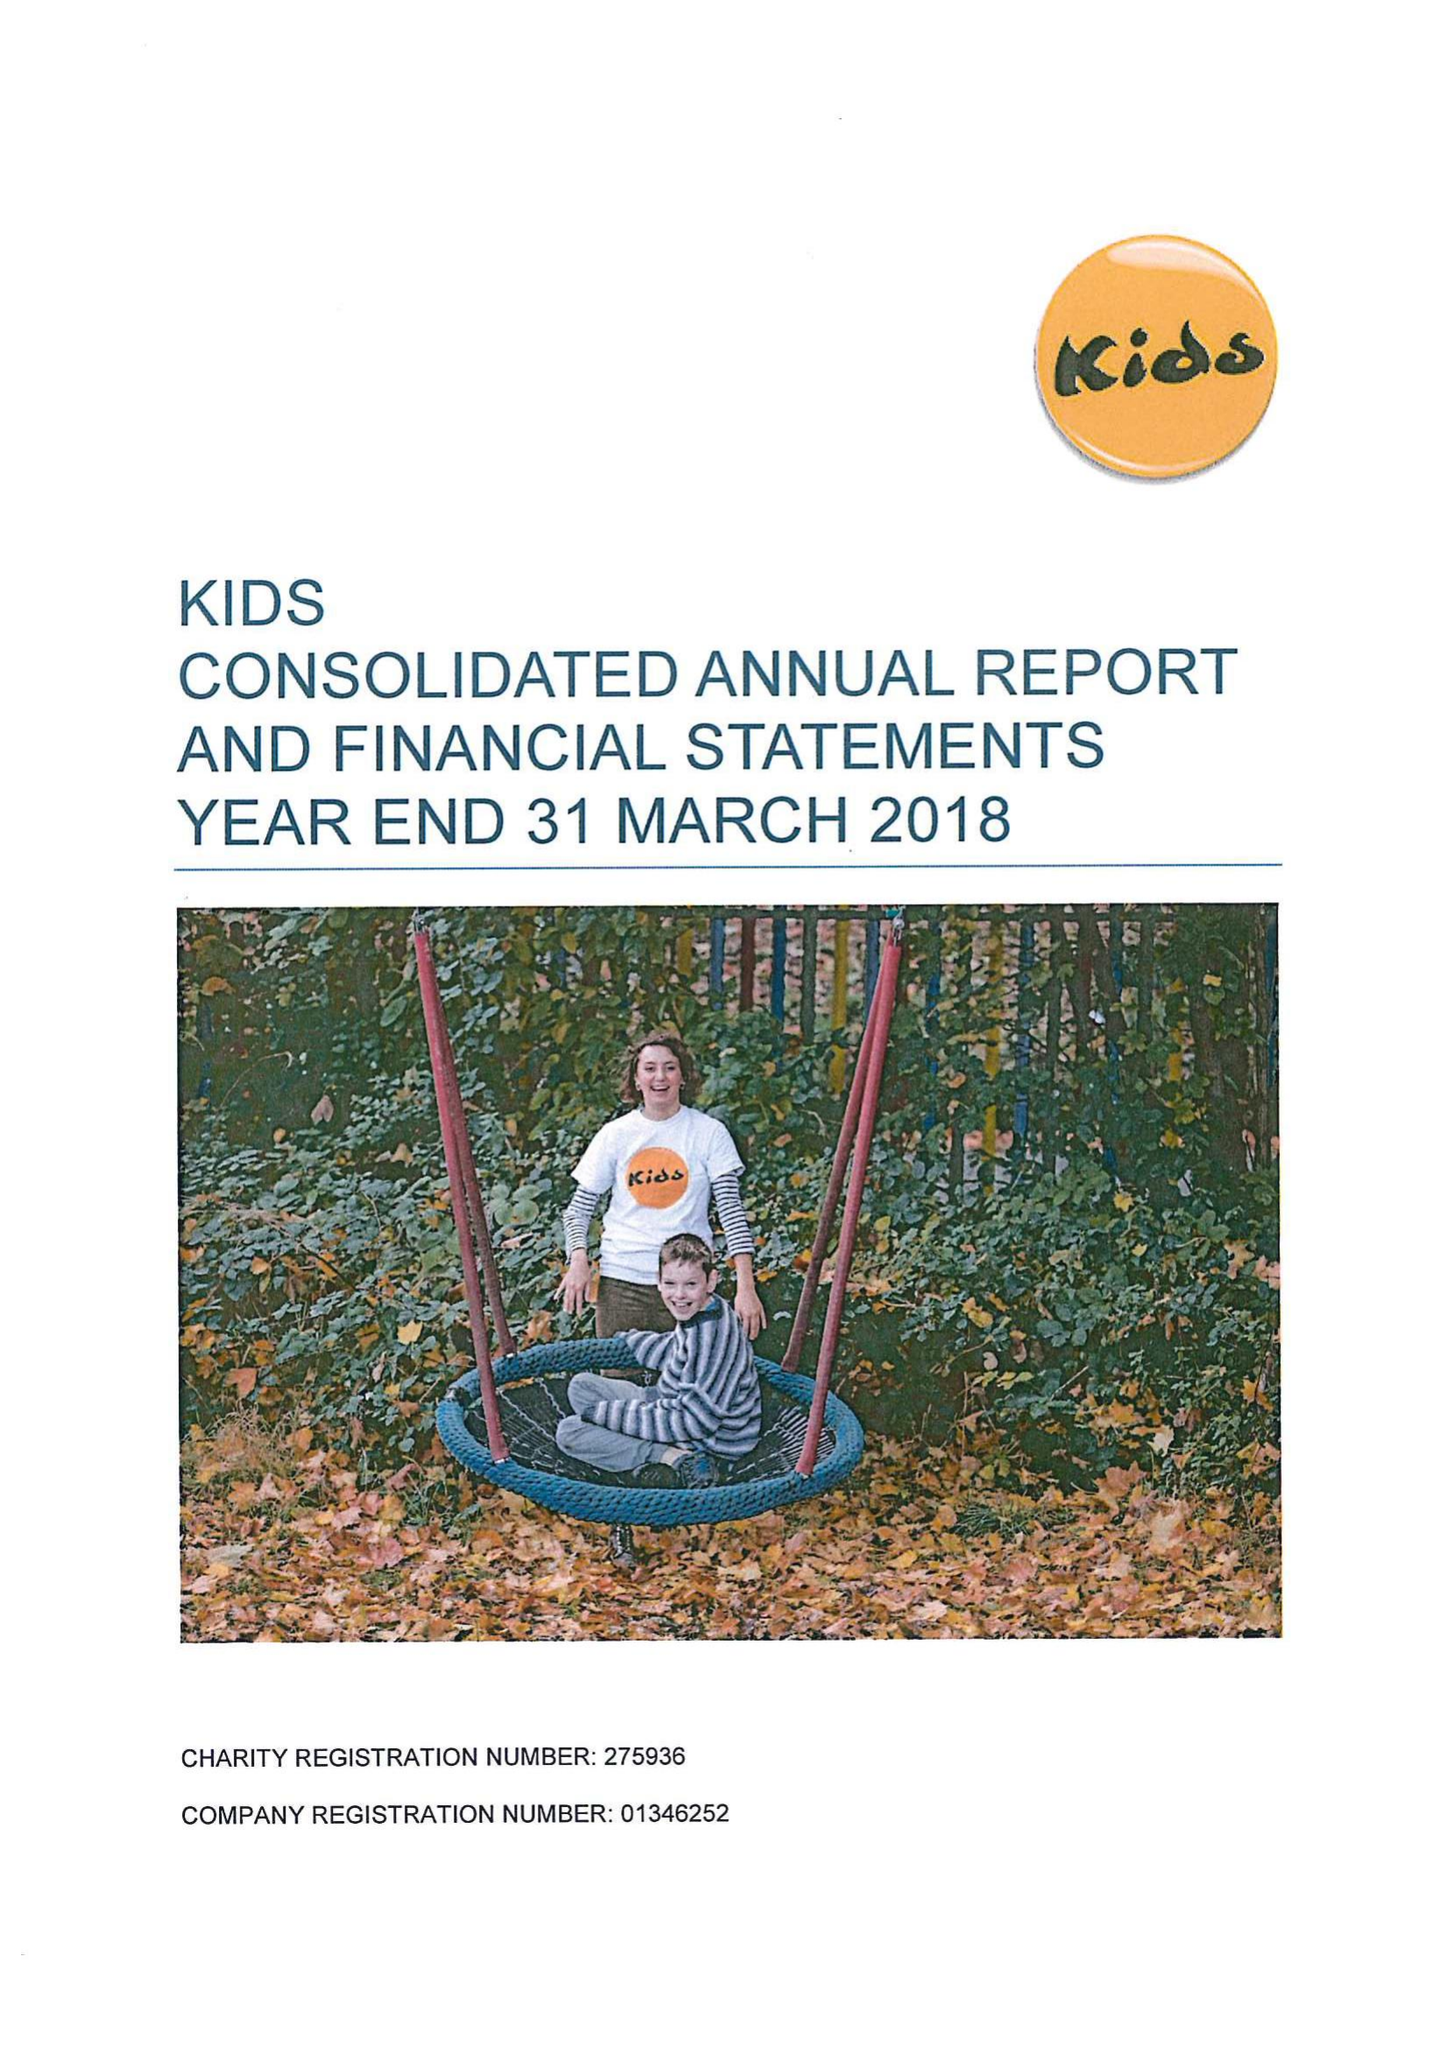What is the value for the income_annually_in_british_pounds?
Answer the question using a single word or phrase. 15724757.00 